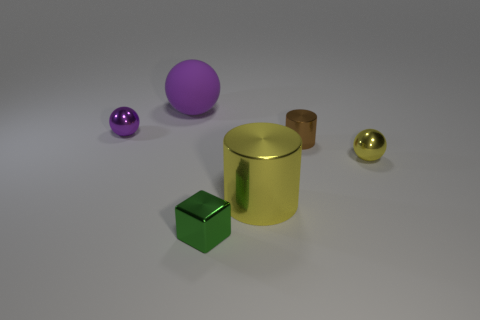Add 4 purple spheres. How many objects exist? 10 Subtract all cylinders. How many objects are left? 4 Subtract all metal cylinders. Subtract all shiny balls. How many objects are left? 2 Add 4 purple rubber balls. How many purple rubber balls are left? 5 Add 5 large purple spheres. How many large purple spheres exist? 6 Subtract 0 yellow blocks. How many objects are left? 6 